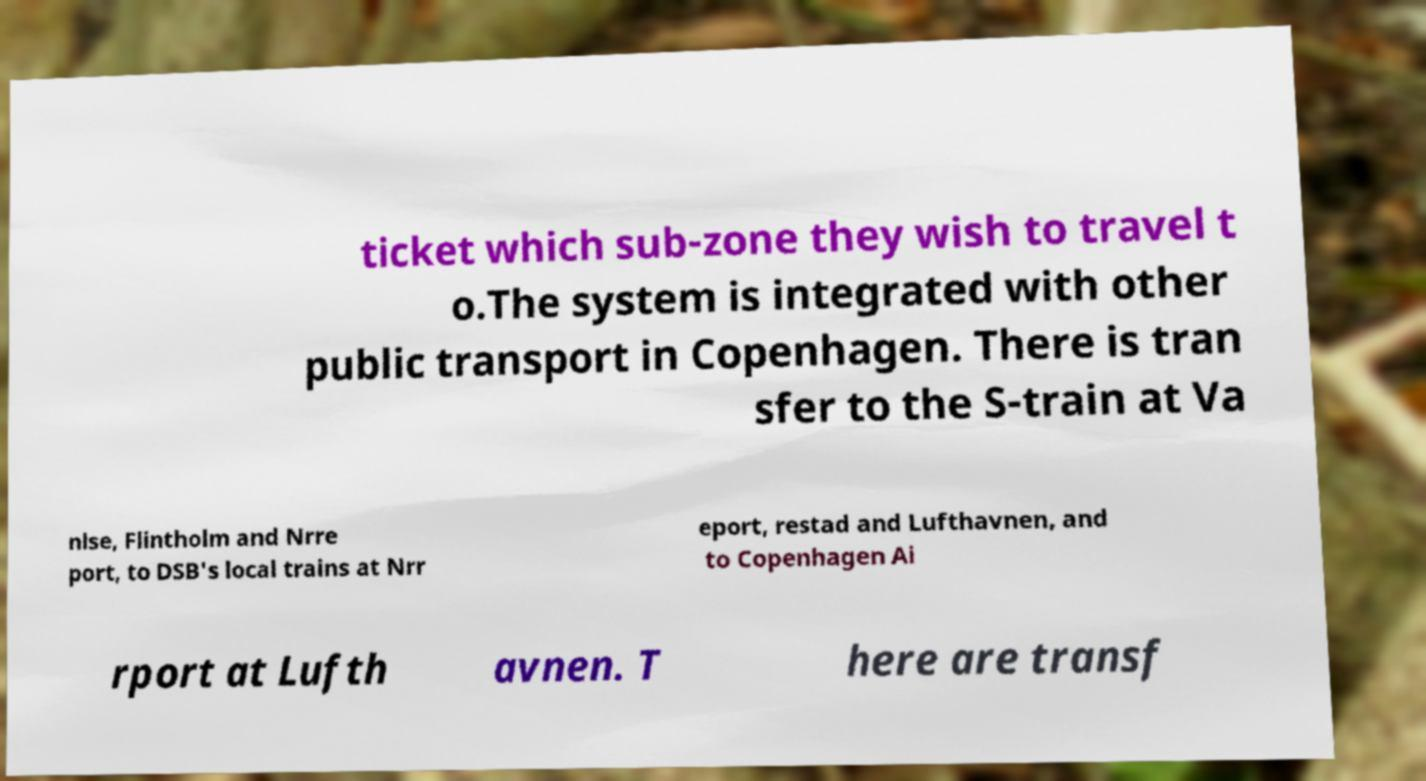Could you assist in decoding the text presented in this image and type it out clearly? ticket which sub-zone they wish to travel t o.The system is integrated with other public transport in Copenhagen. There is tran sfer to the S-train at Va nlse, Flintholm and Nrre port, to DSB's local trains at Nrr eport, restad and Lufthavnen, and to Copenhagen Ai rport at Lufth avnen. T here are transf 